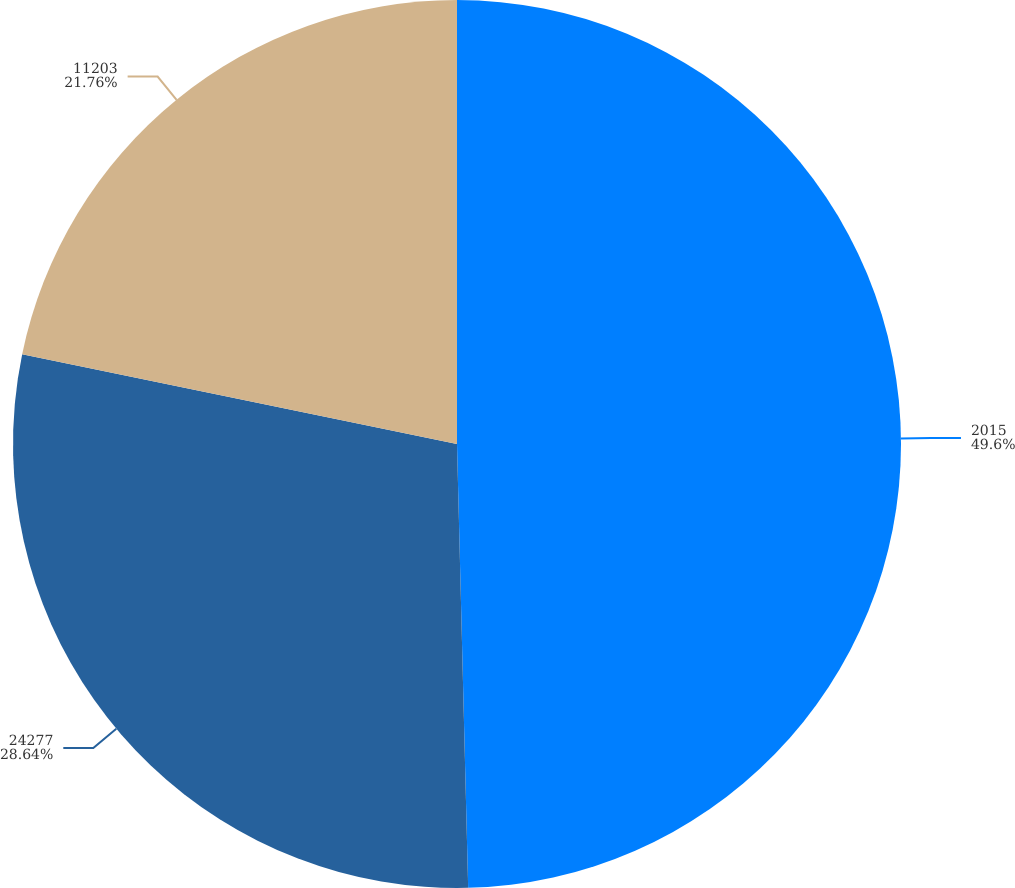Convert chart to OTSL. <chart><loc_0><loc_0><loc_500><loc_500><pie_chart><fcel>2015<fcel>24277<fcel>11203<nl><fcel>49.6%<fcel>28.64%<fcel>21.76%<nl></chart> 